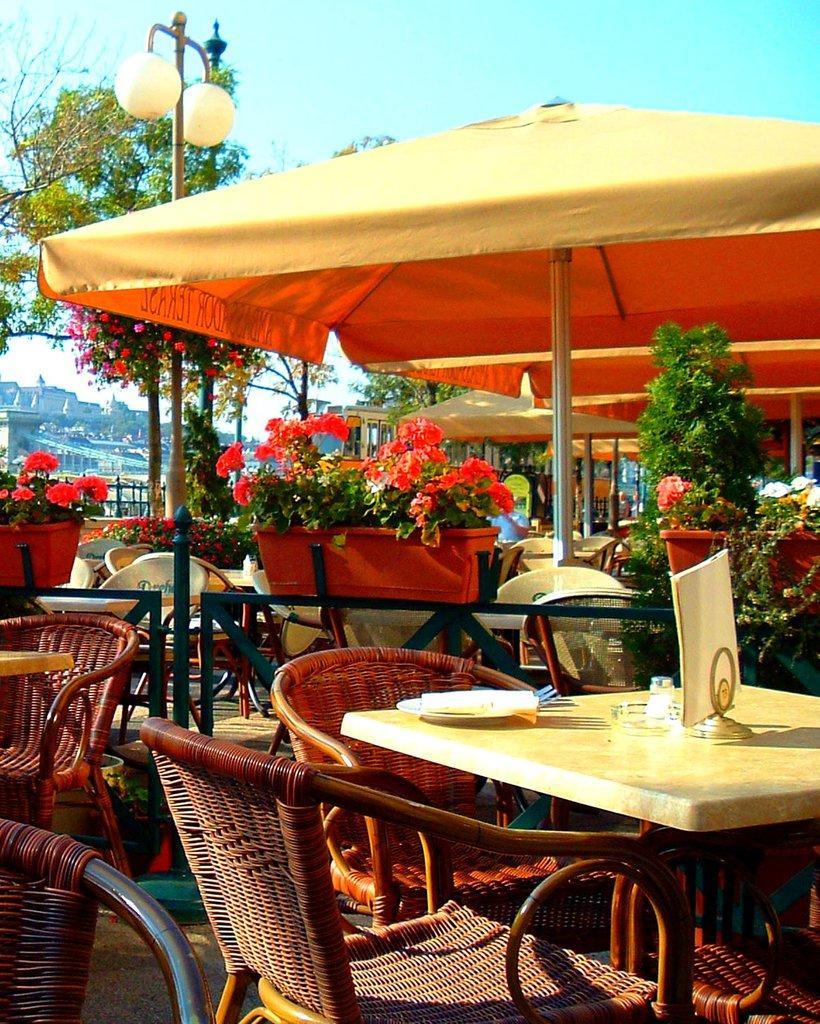Can you describe this image briefly? This image looks like a restaurant. In which we can see many tables and chairs along with potted plants. At the top, there are tents. And we can see the buildings. At the top, there is sky. 